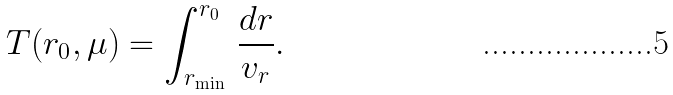Convert formula to latex. <formula><loc_0><loc_0><loc_500><loc_500>T ( r _ { 0 } , \mu ) = \int ^ { r _ { 0 } } _ { r _ { \min } } \, \frac { d r } { v _ { r } } .</formula> 